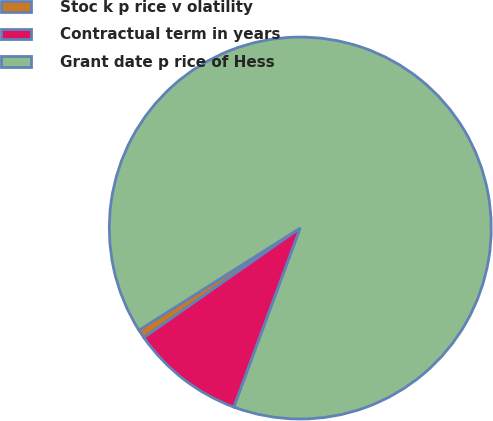Convert chart to OTSL. <chart><loc_0><loc_0><loc_500><loc_500><pie_chart><fcel>Stoc k p rice v olatility<fcel>Contractual term in years<fcel>Grant date p rice of Hess<nl><fcel>0.74%<fcel>9.63%<fcel>89.63%<nl></chart> 